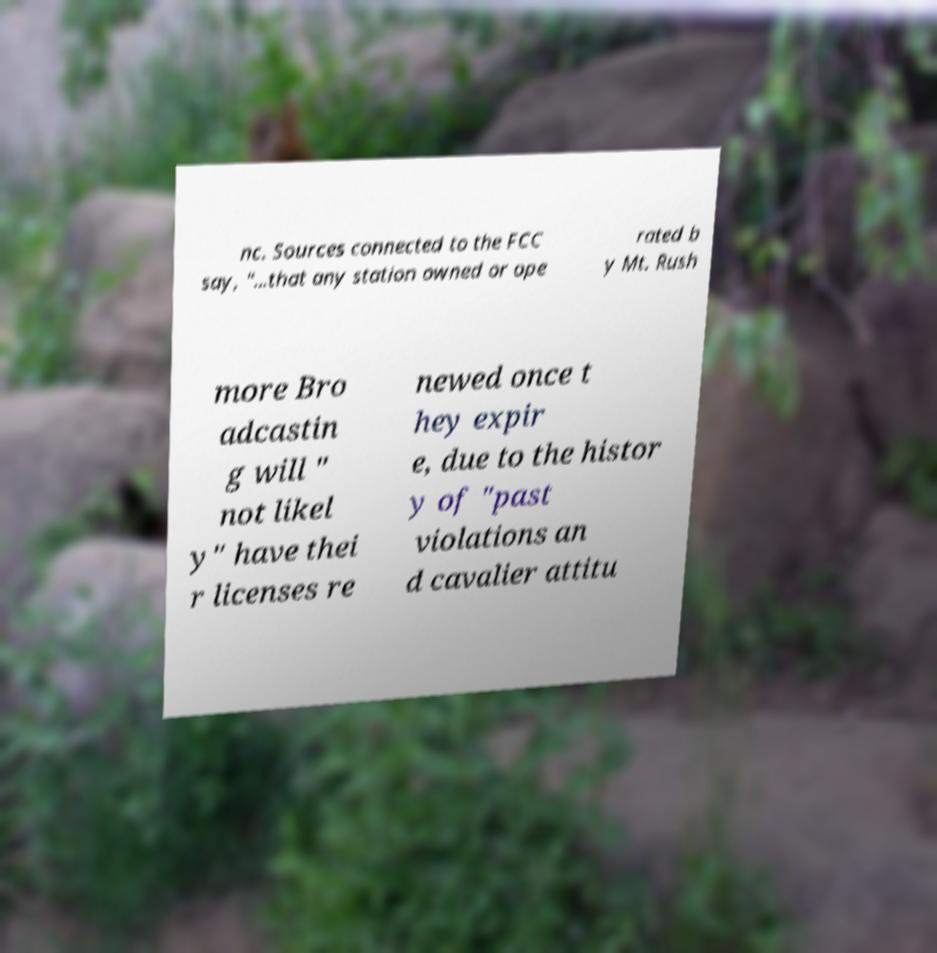Could you extract and type out the text from this image? nc. Sources connected to the FCC say, "...that any station owned or ope rated b y Mt. Rush more Bro adcastin g will " not likel y" have thei r licenses re newed once t hey expir e, due to the histor y of "past violations an d cavalier attitu 